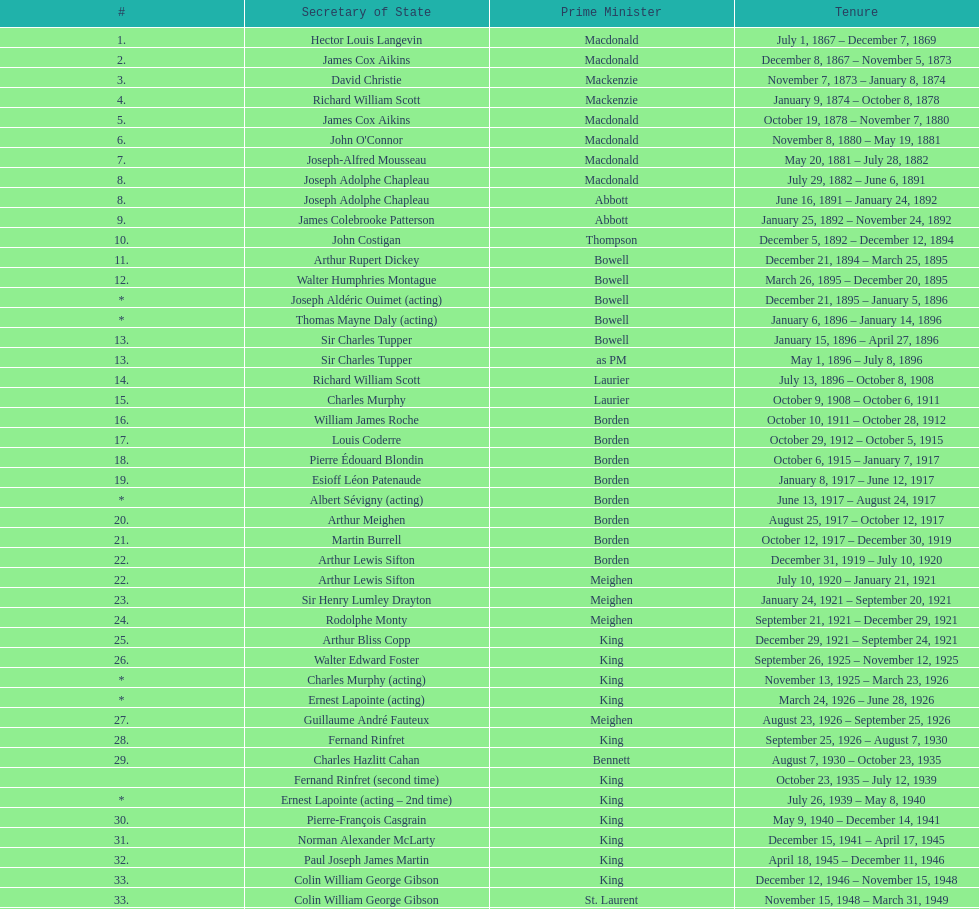Was macdonald prime minister before or after bowell? Before. 